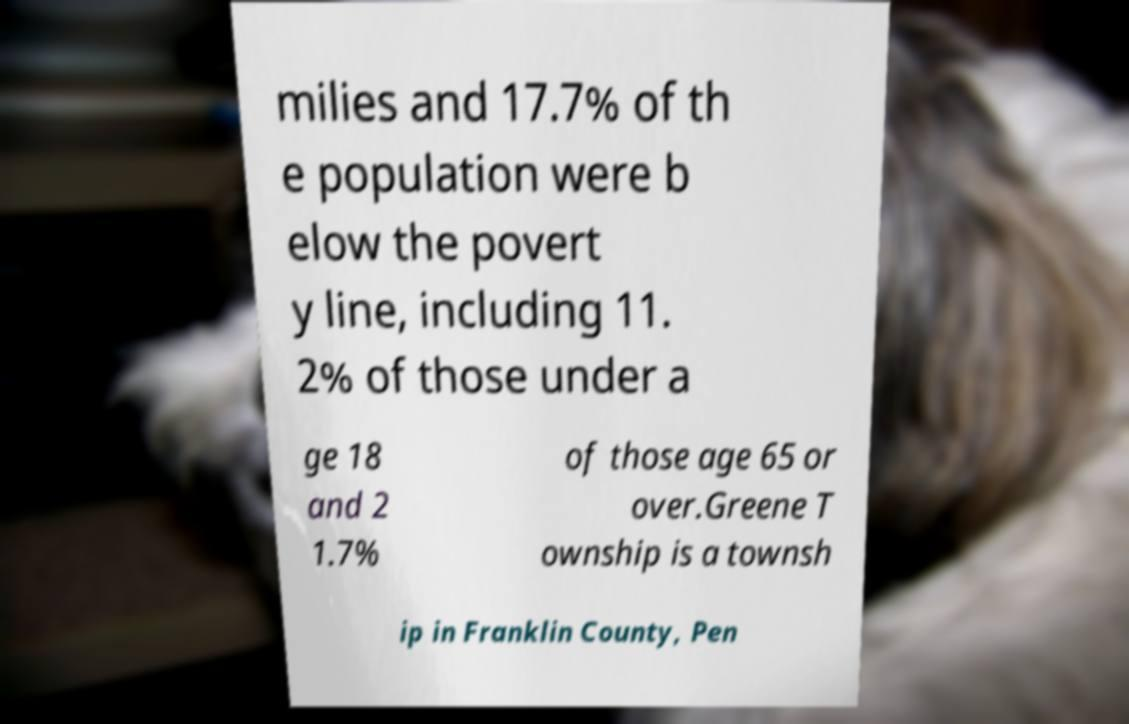I need the written content from this picture converted into text. Can you do that? milies and 17.7% of th e population were b elow the povert y line, including 11. 2% of those under a ge 18 and 2 1.7% of those age 65 or over.Greene T ownship is a townsh ip in Franklin County, Pen 